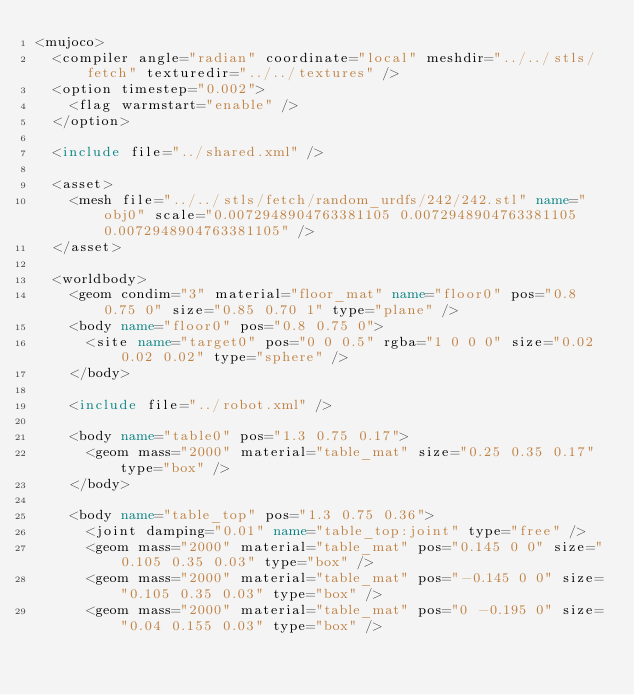<code> <loc_0><loc_0><loc_500><loc_500><_XML_><mujoco>
	<compiler angle="radian" coordinate="local" meshdir="../../stls/fetch" texturedir="../../textures" />
	<option timestep="0.002">
		<flag warmstart="enable" />
	</option>

	<include file="../shared.xml" />

	<asset>
		<mesh file="../../stls/fetch/random_urdfs/242/242.stl" name="obj0" scale="0.0072948904763381105 0.0072948904763381105 0.0072948904763381105" />
	</asset>

	<worldbody>
		<geom condim="3" material="floor_mat" name="floor0" pos="0.8 0.75 0" size="0.85 0.70 1" type="plane" />
		<body name="floor0" pos="0.8 0.75 0">
			<site name="target0" pos="0 0 0.5" rgba="1 0 0 0" size="0.02 0.02 0.02" type="sphere" />
		</body>

		<include file="../robot.xml" />

		<body name="table0" pos="1.3 0.75 0.17">
			<geom mass="2000" material="table_mat" size="0.25 0.35 0.17" type="box" />
		</body>

		<body name="table_top" pos="1.3 0.75 0.36">
			<joint damping="0.01" name="table_top:joint" type="free" />
			<geom mass="2000" material="table_mat" pos="0.145 0 0" size="0.105 0.35 0.03" type="box" />
			<geom mass="2000" material="table_mat" pos="-0.145 0 0" size="0.105 0.35 0.03" type="box" />
			<geom mass="2000" material="table_mat" pos="0 -0.195 0" size="0.04 0.155 0.03" type="box" /></code> 